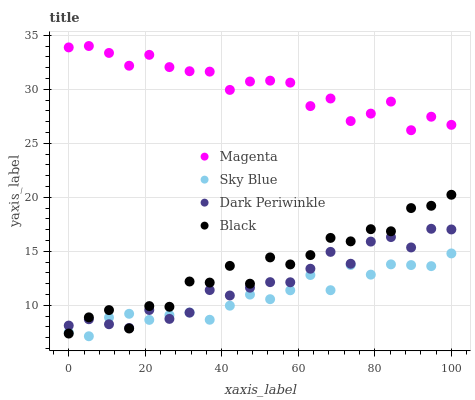Does Sky Blue have the minimum area under the curve?
Answer yes or no. Yes. Does Magenta have the maximum area under the curve?
Answer yes or no. Yes. Does Black have the minimum area under the curve?
Answer yes or no. No. Does Black have the maximum area under the curve?
Answer yes or no. No. Is Sky Blue the smoothest?
Answer yes or no. Yes. Is Black the roughest?
Answer yes or no. Yes. Is Magenta the smoothest?
Answer yes or no. No. Is Magenta the roughest?
Answer yes or no. No. Does Sky Blue have the lowest value?
Answer yes or no. Yes. Does Black have the lowest value?
Answer yes or no. No. Does Magenta have the highest value?
Answer yes or no. Yes. Does Black have the highest value?
Answer yes or no. No. Is Sky Blue less than Magenta?
Answer yes or no. Yes. Is Magenta greater than Dark Periwinkle?
Answer yes or no. Yes. Does Sky Blue intersect Black?
Answer yes or no. Yes. Is Sky Blue less than Black?
Answer yes or no. No. Is Sky Blue greater than Black?
Answer yes or no. No. Does Sky Blue intersect Magenta?
Answer yes or no. No. 